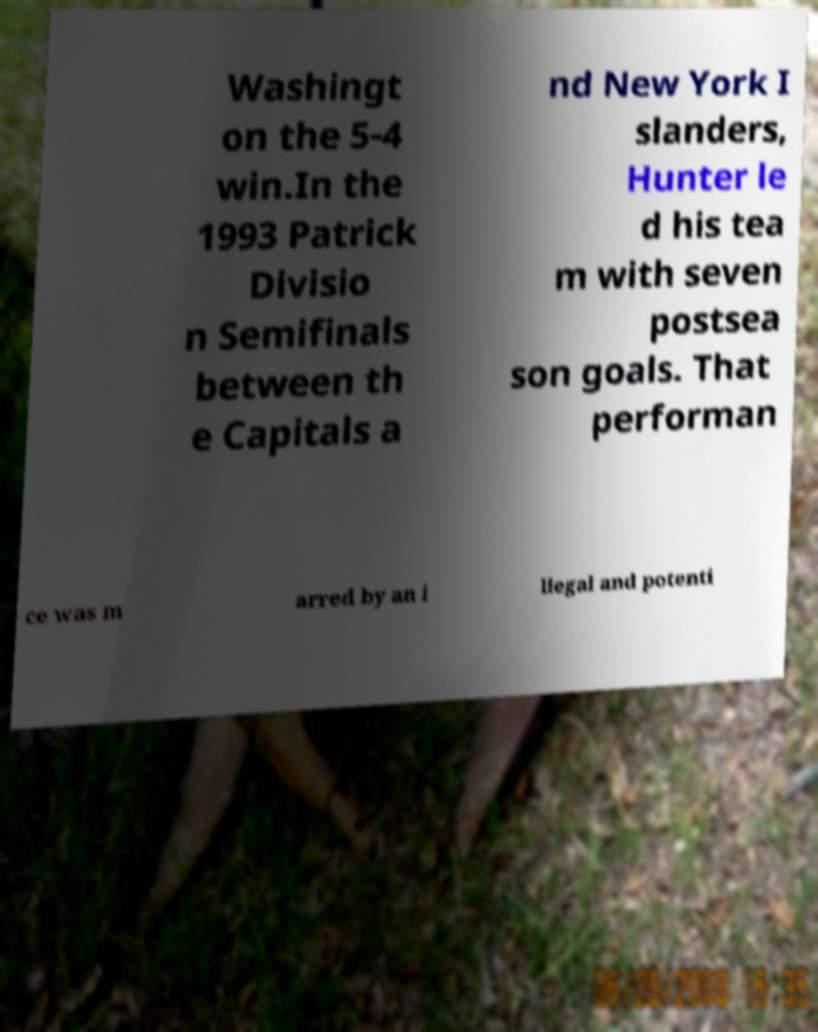Could you assist in decoding the text presented in this image and type it out clearly? Washingt on the 5-4 win.In the 1993 Patrick Divisio n Semifinals between th e Capitals a nd New York I slanders, Hunter le d his tea m with seven postsea son goals. That performan ce was m arred by an i llegal and potenti 